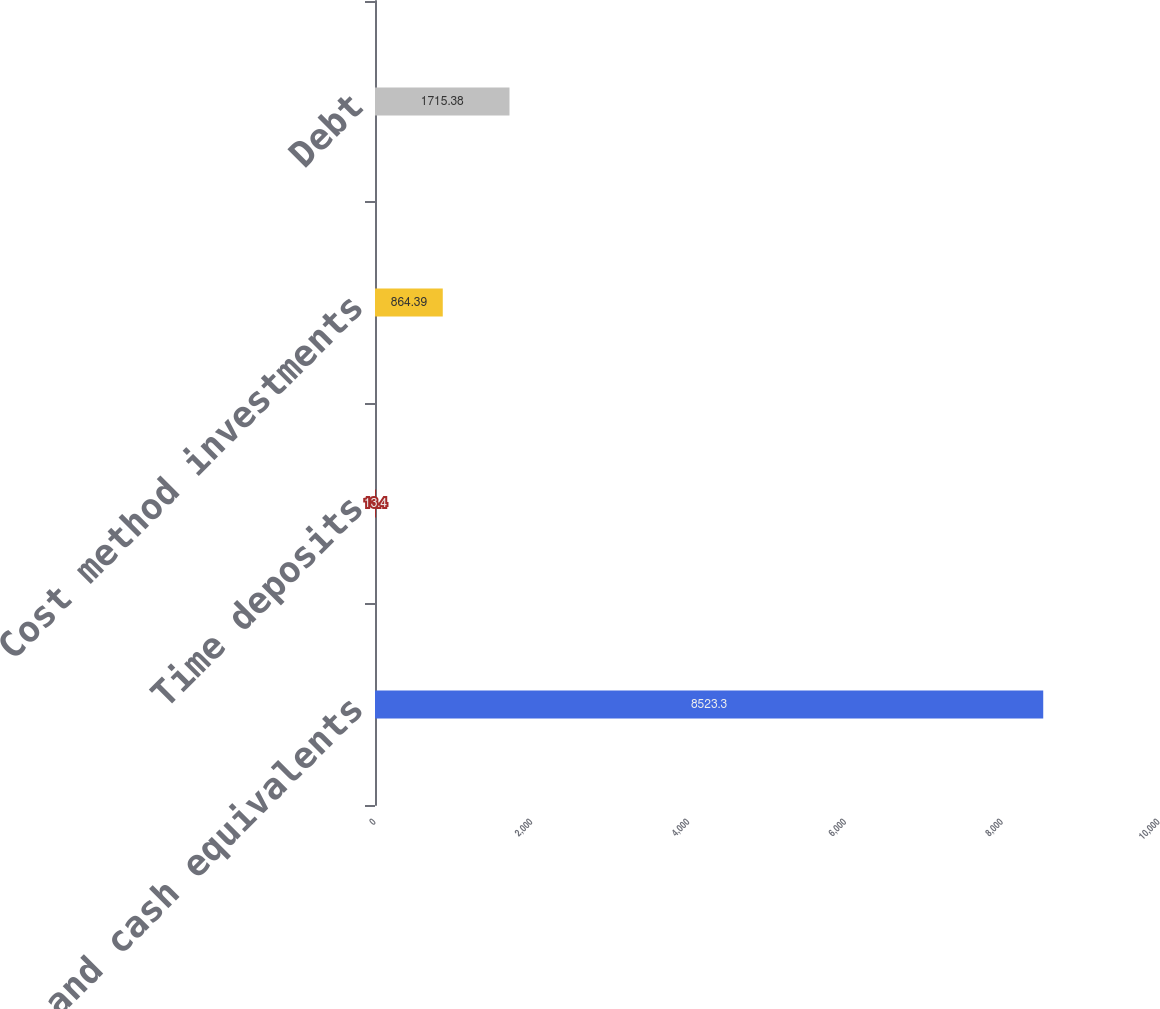Convert chart. <chart><loc_0><loc_0><loc_500><loc_500><bar_chart><fcel>Cash and cash equivalents<fcel>Time deposits<fcel>Cost method investments<fcel>Debt<nl><fcel>8523.3<fcel>13.4<fcel>864.39<fcel>1715.38<nl></chart> 